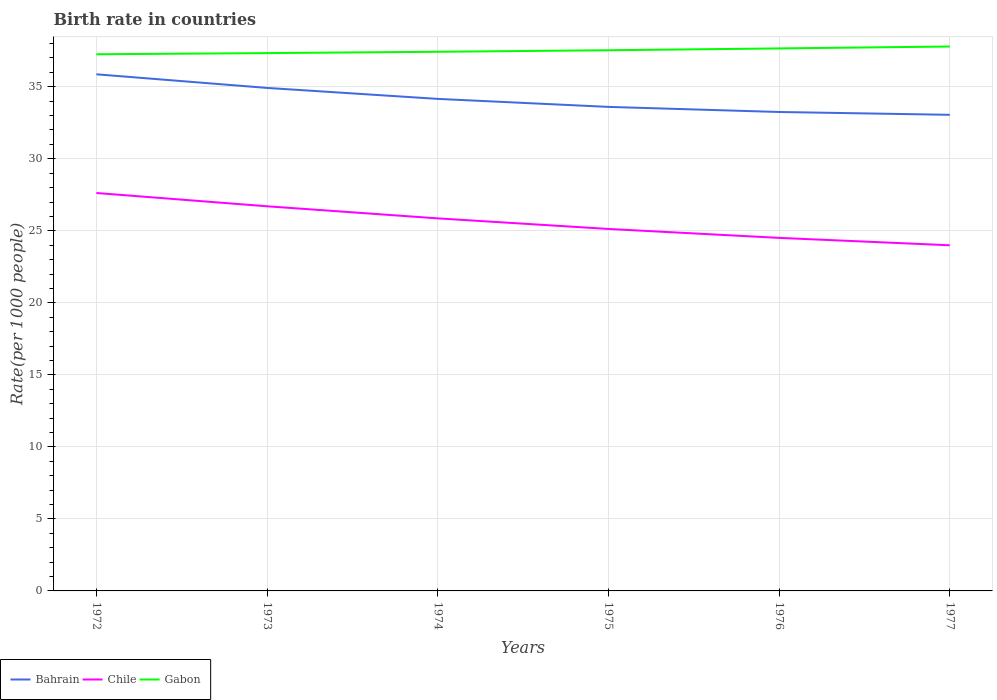Does the line corresponding to Bahrain intersect with the line corresponding to Gabon?
Give a very brief answer. No. Is the number of lines equal to the number of legend labels?
Your answer should be compact. Yes. Across all years, what is the maximum birth rate in Bahrain?
Give a very brief answer. 33.05. What is the total birth rate in Gabon in the graph?
Your response must be concise. -0.08. What is the difference between the highest and the second highest birth rate in Bahrain?
Your response must be concise. 2.81. Is the birth rate in Bahrain strictly greater than the birth rate in Gabon over the years?
Offer a very short reply. Yes. Are the values on the major ticks of Y-axis written in scientific E-notation?
Your answer should be very brief. No. Does the graph contain any zero values?
Make the answer very short. No. Where does the legend appear in the graph?
Make the answer very short. Bottom left. What is the title of the graph?
Ensure brevity in your answer.  Birth rate in countries. Does "India" appear as one of the legend labels in the graph?
Your answer should be compact. No. What is the label or title of the X-axis?
Provide a short and direct response. Years. What is the label or title of the Y-axis?
Give a very brief answer. Rate(per 1000 people). What is the Rate(per 1000 people) in Bahrain in 1972?
Your answer should be compact. 35.87. What is the Rate(per 1000 people) in Chile in 1972?
Offer a very short reply. 27.63. What is the Rate(per 1000 people) in Gabon in 1972?
Ensure brevity in your answer.  37.26. What is the Rate(per 1000 people) of Bahrain in 1973?
Offer a very short reply. 34.92. What is the Rate(per 1000 people) in Chile in 1973?
Your response must be concise. 26.7. What is the Rate(per 1000 people) of Gabon in 1973?
Make the answer very short. 37.34. What is the Rate(per 1000 people) of Bahrain in 1974?
Keep it short and to the point. 34.16. What is the Rate(per 1000 people) in Chile in 1974?
Your answer should be very brief. 25.86. What is the Rate(per 1000 people) of Gabon in 1974?
Provide a succinct answer. 37.43. What is the Rate(per 1000 people) in Bahrain in 1975?
Ensure brevity in your answer.  33.6. What is the Rate(per 1000 people) in Chile in 1975?
Offer a terse response. 25.13. What is the Rate(per 1000 people) of Gabon in 1975?
Offer a terse response. 37.54. What is the Rate(per 1000 people) of Bahrain in 1976?
Give a very brief answer. 33.25. What is the Rate(per 1000 people) in Chile in 1976?
Ensure brevity in your answer.  24.51. What is the Rate(per 1000 people) of Gabon in 1976?
Your answer should be compact. 37.66. What is the Rate(per 1000 people) in Bahrain in 1977?
Offer a terse response. 33.05. What is the Rate(per 1000 people) of Chile in 1977?
Your response must be concise. 24. What is the Rate(per 1000 people) in Gabon in 1977?
Ensure brevity in your answer.  37.8. Across all years, what is the maximum Rate(per 1000 people) of Bahrain?
Keep it short and to the point. 35.87. Across all years, what is the maximum Rate(per 1000 people) in Chile?
Offer a terse response. 27.63. Across all years, what is the maximum Rate(per 1000 people) of Gabon?
Provide a short and direct response. 37.8. Across all years, what is the minimum Rate(per 1000 people) in Bahrain?
Keep it short and to the point. 33.05. Across all years, what is the minimum Rate(per 1000 people) of Chile?
Provide a succinct answer. 24. Across all years, what is the minimum Rate(per 1000 people) in Gabon?
Offer a very short reply. 37.26. What is the total Rate(per 1000 people) in Bahrain in the graph?
Your response must be concise. 204.86. What is the total Rate(per 1000 people) of Chile in the graph?
Your answer should be compact. 153.83. What is the total Rate(per 1000 people) of Gabon in the graph?
Keep it short and to the point. 225.02. What is the difference between the Rate(per 1000 people) of Bahrain in 1972 and that in 1973?
Your answer should be compact. 0.95. What is the difference between the Rate(per 1000 people) of Chile in 1972 and that in 1973?
Provide a succinct answer. 0.92. What is the difference between the Rate(per 1000 people) in Gabon in 1972 and that in 1973?
Offer a very short reply. -0.08. What is the difference between the Rate(per 1000 people) of Bahrain in 1972 and that in 1974?
Your answer should be compact. 1.71. What is the difference between the Rate(per 1000 people) in Chile in 1972 and that in 1974?
Your answer should be compact. 1.76. What is the difference between the Rate(per 1000 people) of Gabon in 1972 and that in 1974?
Your answer should be very brief. -0.17. What is the difference between the Rate(per 1000 people) of Bahrain in 1972 and that in 1975?
Give a very brief answer. 2.26. What is the difference between the Rate(per 1000 people) in Chile in 1972 and that in 1975?
Ensure brevity in your answer.  2.5. What is the difference between the Rate(per 1000 people) of Gabon in 1972 and that in 1975?
Make the answer very short. -0.28. What is the difference between the Rate(per 1000 people) in Bahrain in 1972 and that in 1976?
Make the answer very short. 2.62. What is the difference between the Rate(per 1000 people) in Chile in 1972 and that in 1976?
Offer a very short reply. 3.12. What is the difference between the Rate(per 1000 people) in Gabon in 1972 and that in 1976?
Provide a succinct answer. -0.41. What is the difference between the Rate(per 1000 people) of Bahrain in 1972 and that in 1977?
Offer a terse response. 2.81. What is the difference between the Rate(per 1000 people) in Chile in 1972 and that in 1977?
Provide a succinct answer. 3.63. What is the difference between the Rate(per 1000 people) of Gabon in 1972 and that in 1977?
Ensure brevity in your answer.  -0.54. What is the difference between the Rate(per 1000 people) in Bahrain in 1973 and that in 1974?
Provide a succinct answer. 0.76. What is the difference between the Rate(per 1000 people) in Chile in 1973 and that in 1974?
Keep it short and to the point. 0.84. What is the difference between the Rate(per 1000 people) in Gabon in 1973 and that in 1974?
Ensure brevity in your answer.  -0.09. What is the difference between the Rate(per 1000 people) of Bahrain in 1973 and that in 1975?
Make the answer very short. 1.32. What is the difference between the Rate(per 1000 people) in Chile in 1973 and that in 1975?
Your answer should be very brief. 1.57. What is the difference between the Rate(per 1000 people) in Gabon in 1973 and that in 1975?
Make the answer very short. -0.2. What is the difference between the Rate(per 1000 people) in Bahrain in 1973 and that in 1976?
Your response must be concise. 1.67. What is the difference between the Rate(per 1000 people) in Chile in 1973 and that in 1976?
Ensure brevity in your answer.  2.19. What is the difference between the Rate(per 1000 people) of Gabon in 1973 and that in 1976?
Offer a terse response. -0.32. What is the difference between the Rate(per 1000 people) in Bahrain in 1973 and that in 1977?
Your response must be concise. 1.87. What is the difference between the Rate(per 1000 people) of Chile in 1973 and that in 1977?
Provide a short and direct response. 2.71. What is the difference between the Rate(per 1000 people) of Gabon in 1973 and that in 1977?
Provide a succinct answer. -0.46. What is the difference between the Rate(per 1000 people) of Bahrain in 1974 and that in 1975?
Provide a succinct answer. 0.56. What is the difference between the Rate(per 1000 people) in Chile in 1974 and that in 1975?
Give a very brief answer. 0.73. What is the difference between the Rate(per 1000 people) of Gabon in 1974 and that in 1975?
Offer a very short reply. -0.11. What is the difference between the Rate(per 1000 people) of Bahrain in 1974 and that in 1976?
Your response must be concise. 0.91. What is the difference between the Rate(per 1000 people) in Chile in 1974 and that in 1976?
Give a very brief answer. 1.35. What is the difference between the Rate(per 1000 people) of Gabon in 1974 and that in 1976?
Your response must be concise. -0.23. What is the difference between the Rate(per 1000 people) of Bahrain in 1974 and that in 1977?
Offer a terse response. 1.11. What is the difference between the Rate(per 1000 people) of Chile in 1974 and that in 1977?
Give a very brief answer. 1.87. What is the difference between the Rate(per 1000 people) in Gabon in 1974 and that in 1977?
Provide a succinct answer. -0.37. What is the difference between the Rate(per 1000 people) of Bahrain in 1975 and that in 1976?
Keep it short and to the point. 0.35. What is the difference between the Rate(per 1000 people) in Chile in 1975 and that in 1976?
Your answer should be compact. 0.62. What is the difference between the Rate(per 1000 people) of Gabon in 1975 and that in 1976?
Offer a terse response. -0.13. What is the difference between the Rate(per 1000 people) in Bahrain in 1975 and that in 1977?
Your answer should be very brief. 0.55. What is the difference between the Rate(per 1000 people) of Chile in 1975 and that in 1977?
Ensure brevity in your answer.  1.13. What is the difference between the Rate(per 1000 people) of Gabon in 1975 and that in 1977?
Your answer should be very brief. -0.26. What is the difference between the Rate(per 1000 people) of Bahrain in 1976 and that in 1977?
Keep it short and to the point. 0.2. What is the difference between the Rate(per 1000 people) in Chile in 1976 and that in 1977?
Make the answer very short. 0.52. What is the difference between the Rate(per 1000 people) in Gabon in 1976 and that in 1977?
Your answer should be compact. -0.13. What is the difference between the Rate(per 1000 people) of Bahrain in 1972 and the Rate(per 1000 people) of Chile in 1973?
Offer a very short reply. 9.16. What is the difference between the Rate(per 1000 people) in Bahrain in 1972 and the Rate(per 1000 people) in Gabon in 1973?
Provide a short and direct response. -1.47. What is the difference between the Rate(per 1000 people) of Chile in 1972 and the Rate(per 1000 people) of Gabon in 1973?
Provide a succinct answer. -9.71. What is the difference between the Rate(per 1000 people) of Bahrain in 1972 and the Rate(per 1000 people) of Chile in 1974?
Keep it short and to the point. 10. What is the difference between the Rate(per 1000 people) of Bahrain in 1972 and the Rate(per 1000 people) of Gabon in 1974?
Offer a very short reply. -1.56. What is the difference between the Rate(per 1000 people) in Chile in 1972 and the Rate(per 1000 people) in Gabon in 1974?
Give a very brief answer. -9.8. What is the difference between the Rate(per 1000 people) of Bahrain in 1972 and the Rate(per 1000 people) of Chile in 1975?
Give a very brief answer. 10.74. What is the difference between the Rate(per 1000 people) of Bahrain in 1972 and the Rate(per 1000 people) of Gabon in 1975?
Provide a short and direct response. -1.67. What is the difference between the Rate(per 1000 people) in Chile in 1972 and the Rate(per 1000 people) in Gabon in 1975?
Offer a very short reply. -9.91. What is the difference between the Rate(per 1000 people) in Bahrain in 1972 and the Rate(per 1000 people) in Chile in 1976?
Your answer should be compact. 11.36. What is the difference between the Rate(per 1000 people) of Bahrain in 1972 and the Rate(per 1000 people) of Gabon in 1976?
Your response must be concise. -1.8. What is the difference between the Rate(per 1000 people) of Chile in 1972 and the Rate(per 1000 people) of Gabon in 1976?
Provide a short and direct response. -10.04. What is the difference between the Rate(per 1000 people) of Bahrain in 1972 and the Rate(per 1000 people) of Chile in 1977?
Offer a terse response. 11.87. What is the difference between the Rate(per 1000 people) in Bahrain in 1972 and the Rate(per 1000 people) in Gabon in 1977?
Offer a very short reply. -1.93. What is the difference between the Rate(per 1000 people) of Chile in 1972 and the Rate(per 1000 people) of Gabon in 1977?
Your answer should be compact. -10.17. What is the difference between the Rate(per 1000 people) in Bahrain in 1973 and the Rate(per 1000 people) in Chile in 1974?
Provide a short and direct response. 9.06. What is the difference between the Rate(per 1000 people) in Bahrain in 1973 and the Rate(per 1000 people) in Gabon in 1974?
Keep it short and to the point. -2.51. What is the difference between the Rate(per 1000 people) in Chile in 1973 and the Rate(per 1000 people) in Gabon in 1974?
Offer a terse response. -10.73. What is the difference between the Rate(per 1000 people) in Bahrain in 1973 and the Rate(per 1000 people) in Chile in 1975?
Keep it short and to the point. 9.79. What is the difference between the Rate(per 1000 people) of Bahrain in 1973 and the Rate(per 1000 people) of Gabon in 1975?
Keep it short and to the point. -2.62. What is the difference between the Rate(per 1000 people) in Chile in 1973 and the Rate(per 1000 people) in Gabon in 1975?
Keep it short and to the point. -10.83. What is the difference between the Rate(per 1000 people) of Bahrain in 1973 and the Rate(per 1000 people) of Chile in 1976?
Provide a short and direct response. 10.41. What is the difference between the Rate(per 1000 people) in Bahrain in 1973 and the Rate(per 1000 people) in Gabon in 1976?
Make the answer very short. -2.74. What is the difference between the Rate(per 1000 people) of Chile in 1973 and the Rate(per 1000 people) of Gabon in 1976?
Keep it short and to the point. -10.96. What is the difference between the Rate(per 1000 people) in Bahrain in 1973 and the Rate(per 1000 people) in Chile in 1977?
Your answer should be very brief. 10.93. What is the difference between the Rate(per 1000 people) in Bahrain in 1973 and the Rate(per 1000 people) in Gabon in 1977?
Make the answer very short. -2.88. What is the difference between the Rate(per 1000 people) of Chile in 1973 and the Rate(per 1000 people) of Gabon in 1977?
Your answer should be very brief. -11.09. What is the difference between the Rate(per 1000 people) in Bahrain in 1974 and the Rate(per 1000 people) in Chile in 1975?
Your answer should be compact. 9.03. What is the difference between the Rate(per 1000 people) in Bahrain in 1974 and the Rate(per 1000 people) in Gabon in 1975?
Offer a terse response. -3.38. What is the difference between the Rate(per 1000 people) in Chile in 1974 and the Rate(per 1000 people) in Gabon in 1975?
Make the answer very short. -11.67. What is the difference between the Rate(per 1000 people) in Bahrain in 1974 and the Rate(per 1000 people) in Chile in 1976?
Ensure brevity in your answer.  9.65. What is the difference between the Rate(per 1000 people) of Bahrain in 1974 and the Rate(per 1000 people) of Gabon in 1976?
Make the answer very short. -3.5. What is the difference between the Rate(per 1000 people) in Chile in 1974 and the Rate(per 1000 people) in Gabon in 1976?
Offer a terse response. -11.8. What is the difference between the Rate(per 1000 people) in Bahrain in 1974 and the Rate(per 1000 people) in Chile in 1977?
Make the answer very short. 10.16. What is the difference between the Rate(per 1000 people) of Bahrain in 1974 and the Rate(per 1000 people) of Gabon in 1977?
Your response must be concise. -3.64. What is the difference between the Rate(per 1000 people) in Chile in 1974 and the Rate(per 1000 people) in Gabon in 1977?
Your response must be concise. -11.93. What is the difference between the Rate(per 1000 people) in Bahrain in 1975 and the Rate(per 1000 people) in Chile in 1976?
Provide a succinct answer. 9.09. What is the difference between the Rate(per 1000 people) in Bahrain in 1975 and the Rate(per 1000 people) in Gabon in 1976?
Your answer should be compact. -4.06. What is the difference between the Rate(per 1000 people) in Chile in 1975 and the Rate(per 1000 people) in Gabon in 1976?
Your response must be concise. -12.53. What is the difference between the Rate(per 1000 people) of Bahrain in 1975 and the Rate(per 1000 people) of Chile in 1977?
Make the answer very short. 9.61. What is the difference between the Rate(per 1000 people) of Bahrain in 1975 and the Rate(per 1000 people) of Gabon in 1977?
Your answer should be very brief. -4.19. What is the difference between the Rate(per 1000 people) of Chile in 1975 and the Rate(per 1000 people) of Gabon in 1977?
Offer a very short reply. -12.67. What is the difference between the Rate(per 1000 people) in Bahrain in 1976 and the Rate(per 1000 people) in Chile in 1977?
Make the answer very short. 9.26. What is the difference between the Rate(per 1000 people) of Bahrain in 1976 and the Rate(per 1000 people) of Gabon in 1977?
Make the answer very short. -4.54. What is the difference between the Rate(per 1000 people) of Chile in 1976 and the Rate(per 1000 people) of Gabon in 1977?
Ensure brevity in your answer.  -13.29. What is the average Rate(per 1000 people) in Bahrain per year?
Keep it short and to the point. 34.14. What is the average Rate(per 1000 people) in Chile per year?
Offer a terse response. 25.64. What is the average Rate(per 1000 people) of Gabon per year?
Ensure brevity in your answer.  37.5. In the year 1972, what is the difference between the Rate(per 1000 people) of Bahrain and Rate(per 1000 people) of Chile?
Give a very brief answer. 8.24. In the year 1972, what is the difference between the Rate(per 1000 people) in Bahrain and Rate(per 1000 people) in Gabon?
Your answer should be very brief. -1.39. In the year 1972, what is the difference between the Rate(per 1000 people) of Chile and Rate(per 1000 people) of Gabon?
Your answer should be compact. -9.63. In the year 1973, what is the difference between the Rate(per 1000 people) in Bahrain and Rate(per 1000 people) in Chile?
Your answer should be compact. 8.22. In the year 1973, what is the difference between the Rate(per 1000 people) in Bahrain and Rate(per 1000 people) in Gabon?
Make the answer very short. -2.42. In the year 1973, what is the difference between the Rate(per 1000 people) in Chile and Rate(per 1000 people) in Gabon?
Provide a succinct answer. -10.63. In the year 1974, what is the difference between the Rate(per 1000 people) in Bahrain and Rate(per 1000 people) in Chile?
Offer a terse response. 8.3. In the year 1974, what is the difference between the Rate(per 1000 people) in Bahrain and Rate(per 1000 people) in Gabon?
Ensure brevity in your answer.  -3.27. In the year 1974, what is the difference between the Rate(per 1000 people) of Chile and Rate(per 1000 people) of Gabon?
Your answer should be very brief. -11.57. In the year 1975, what is the difference between the Rate(per 1000 people) in Bahrain and Rate(per 1000 people) in Chile?
Ensure brevity in your answer.  8.47. In the year 1975, what is the difference between the Rate(per 1000 people) of Bahrain and Rate(per 1000 people) of Gabon?
Ensure brevity in your answer.  -3.93. In the year 1975, what is the difference between the Rate(per 1000 people) in Chile and Rate(per 1000 people) in Gabon?
Provide a short and direct response. -12.41. In the year 1976, what is the difference between the Rate(per 1000 people) of Bahrain and Rate(per 1000 people) of Chile?
Ensure brevity in your answer.  8.74. In the year 1976, what is the difference between the Rate(per 1000 people) in Bahrain and Rate(per 1000 people) in Gabon?
Provide a succinct answer. -4.41. In the year 1976, what is the difference between the Rate(per 1000 people) of Chile and Rate(per 1000 people) of Gabon?
Offer a terse response. -13.15. In the year 1977, what is the difference between the Rate(per 1000 people) in Bahrain and Rate(per 1000 people) in Chile?
Your answer should be very brief. 9.06. In the year 1977, what is the difference between the Rate(per 1000 people) of Bahrain and Rate(per 1000 people) of Gabon?
Provide a short and direct response. -4.74. In the year 1977, what is the difference between the Rate(per 1000 people) in Chile and Rate(per 1000 people) in Gabon?
Make the answer very short. -13.8. What is the ratio of the Rate(per 1000 people) of Bahrain in 1972 to that in 1973?
Make the answer very short. 1.03. What is the ratio of the Rate(per 1000 people) of Chile in 1972 to that in 1973?
Your response must be concise. 1.03. What is the ratio of the Rate(per 1000 people) of Gabon in 1972 to that in 1973?
Make the answer very short. 1. What is the ratio of the Rate(per 1000 people) of Bahrain in 1972 to that in 1974?
Offer a terse response. 1.05. What is the ratio of the Rate(per 1000 people) in Chile in 1972 to that in 1974?
Your answer should be very brief. 1.07. What is the ratio of the Rate(per 1000 people) in Gabon in 1972 to that in 1974?
Offer a terse response. 1. What is the ratio of the Rate(per 1000 people) of Bahrain in 1972 to that in 1975?
Ensure brevity in your answer.  1.07. What is the ratio of the Rate(per 1000 people) of Chile in 1972 to that in 1975?
Make the answer very short. 1.1. What is the ratio of the Rate(per 1000 people) of Bahrain in 1972 to that in 1976?
Provide a short and direct response. 1.08. What is the ratio of the Rate(per 1000 people) in Chile in 1972 to that in 1976?
Offer a terse response. 1.13. What is the ratio of the Rate(per 1000 people) in Bahrain in 1972 to that in 1977?
Offer a very short reply. 1.09. What is the ratio of the Rate(per 1000 people) in Chile in 1972 to that in 1977?
Ensure brevity in your answer.  1.15. What is the ratio of the Rate(per 1000 people) of Gabon in 1972 to that in 1977?
Keep it short and to the point. 0.99. What is the ratio of the Rate(per 1000 people) in Bahrain in 1973 to that in 1974?
Your answer should be compact. 1.02. What is the ratio of the Rate(per 1000 people) in Chile in 1973 to that in 1974?
Provide a succinct answer. 1.03. What is the ratio of the Rate(per 1000 people) in Gabon in 1973 to that in 1974?
Your answer should be very brief. 1. What is the ratio of the Rate(per 1000 people) in Bahrain in 1973 to that in 1975?
Your answer should be very brief. 1.04. What is the ratio of the Rate(per 1000 people) of Chile in 1973 to that in 1975?
Keep it short and to the point. 1.06. What is the ratio of the Rate(per 1000 people) of Bahrain in 1973 to that in 1976?
Your answer should be compact. 1.05. What is the ratio of the Rate(per 1000 people) of Chile in 1973 to that in 1976?
Provide a short and direct response. 1.09. What is the ratio of the Rate(per 1000 people) in Bahrain in 1973 to that in 1977?
Make the answer very short. 1.06. What is the ratio of the Rate(per 1000 people) in Chile in 1973 to that in 1977?
Your response must be concise. 1.11. What is the ratio of the Rate(per 1000 people) in Gabon in 1973 to that in 1977?
Offer a terse response. 0.99. What is the ratio of the Rate(per 1000 people) in Bahrain in 1974 to that in 1975?
Offer a very short reply. 1.02. What is the ratio of the Rate(per 1000 people) of Chile in 1974 to that in 1975?
Your answer should be compact. 1.03. What is the ratio of the Rate(per 1000 people) of Bahrain in 1974 to that in 1976?
Your response must be concise. 1.03. What is the ratio of the Rate(per 1000 people) in Chile in 1974 to that in 1976?
Offer a very short reply. 1.06. What is the ratio of the Rate(per 1000 people) of Gabon in 1974 to that in 1976?
Your response must be concise. 0.99. What is the ratio of the Rate(per 1000 people) of Bahrain in 1974 to that in 1977?
Your answer should be very brief. 1.03. What is the ratio of the Rate(per 1000 people) of Chile in 1974 to that in 1977?
Provide a succinct answer. 1.08. What is the ratio of the Rate(per 1000 people) of Gabon in 1974 to that in 1977?
Your answer should be very brief. 0.99. What is the ratio of the Rate(per 1000 people) in Bahrain in 1975 to that in 1976?
Keep it short and to the point. 1.01. What is the ratio of the Rate(per 1000 people) in Chile in 1975 to that in 1976?
Give a very brief answer. 1.03. What is the ratio of the Rate(per 1000 people) of Gabon in 1975 to that in 1976?
Keep it short and to the point. 1. What is the ratio of the Rate(per 1000 people) of Bahrain in 1975 to that in 1977?
Keep it short and to the point. 1.02. What is the ratio of the Rate(per 1000 people) of Chile in 1975 to that in 1977?
Provide a short and direct response. 1.05. What is the ratio of the Rate(per 1000 people) in Bahrain in 1976 to that in 1977?
Make the answer very short. 1.01. What is the ratio of the Rate(per 1000 people) in Chile in 1976 to that in 1977?
Your answer should be very brief. 1.02. What is the ratio of the Rate(per 1000 people) of Gabon in 1976 to that in 1977?
Provide a short and direct response. 1. What is the difference between the highest and the second highest Rate(per 1000 people) of Bahrain?
Provide a succinct answer. 0.95. What is the difference between the highest and the second highest Rate(per 1000 people) in Chile?
Your answer should be very brief. 0.92. What is the difference between the highest and the second highest Rate(per 1000 people) of Gabon?
Provide a short and direct response. 0.13. What is the difference between the highest and the lowest Rate(per 1000 people) of Bahrain?
Keep it short and to the point. 2.81. What is the difference between the highest and the lowest Rate(per 1000 people) of Chile?
Offer a very short reply. 3.63. What is the difference between the highest and the lowest Rate(per 1000 people) of Gabon?
Your answer should be very brief. 0.54. 